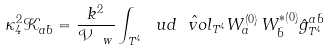Convert formula to latex. <formula><loc_0><loc_0><loc_500><loc_500>\kappa _ { 4 } ^ { 2 } \mathcal { K } _ { a \bar { b } } = \frac { k ^ { 2 } } { \mathcal { V } _ { \ w } } \int _ { T ^ { 4 } } \ u d \hat { \ v o l } _ { T ^ { 4 } } W ^ { \left ( 0 \right ) } _ { a } \, W ^ { \ast \left ( 0 \right ) } _ { \bar { b } } \hat { g } ^ { a \bar { b } } _ { T ^ { 4 } }</formula> 